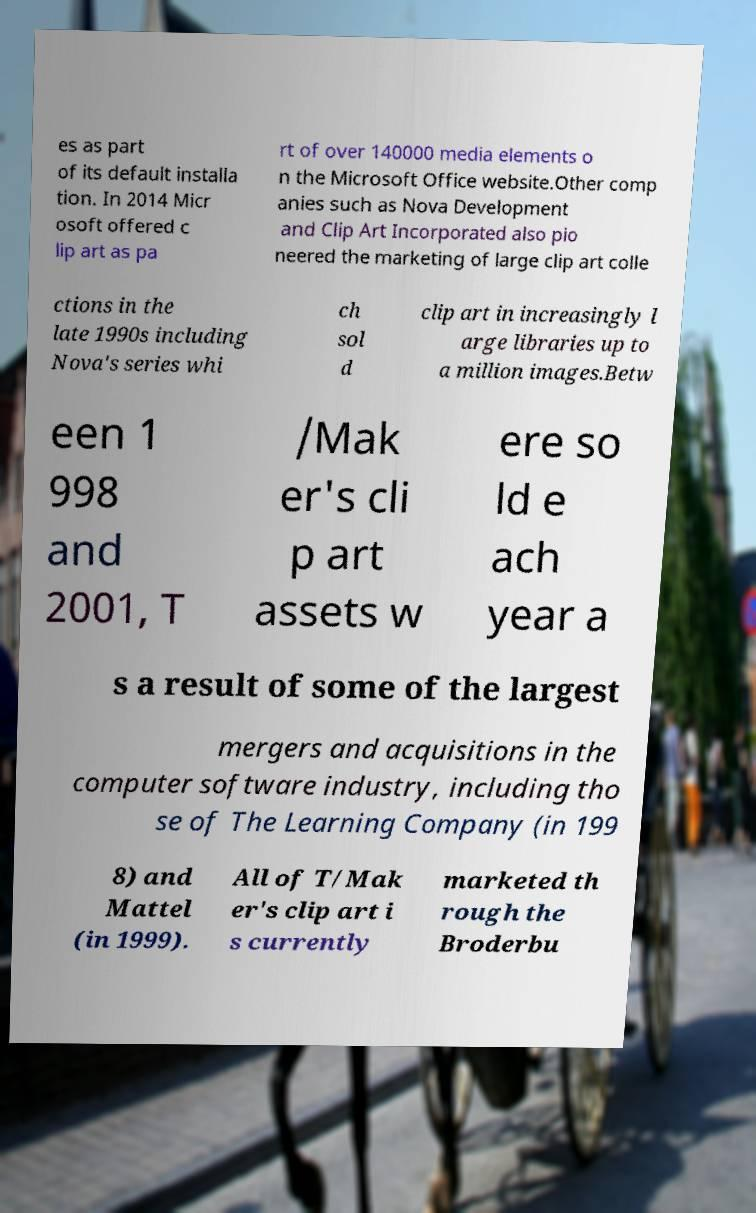What messages or text are displayed in this image? I need them in a readable, typed format. es as part of its default installa tion. In 2014 Micr osoft offered c lip art as pa rt of over 140000 media elements o n the Microsoft Office website.Other comp anies such as Nova Development and Clip Art Incorporated also pio neered the marketing of large clip art colle ctions in the late 1990s including Nova's series whi ch sol d clip art in increasingly l arge libraries up to a million images.Betw een 1 998 and 2001, T /Mak er's cli p art assets w ere so ld e ach year a s a result of some of the largest mergers and acquisitions in the computer software industry, including tho se of The Learning Company (in 199 8) and Mattel (in 1999). All of T/Mak er's clip art i s currently marketed th rough the Broderbu 